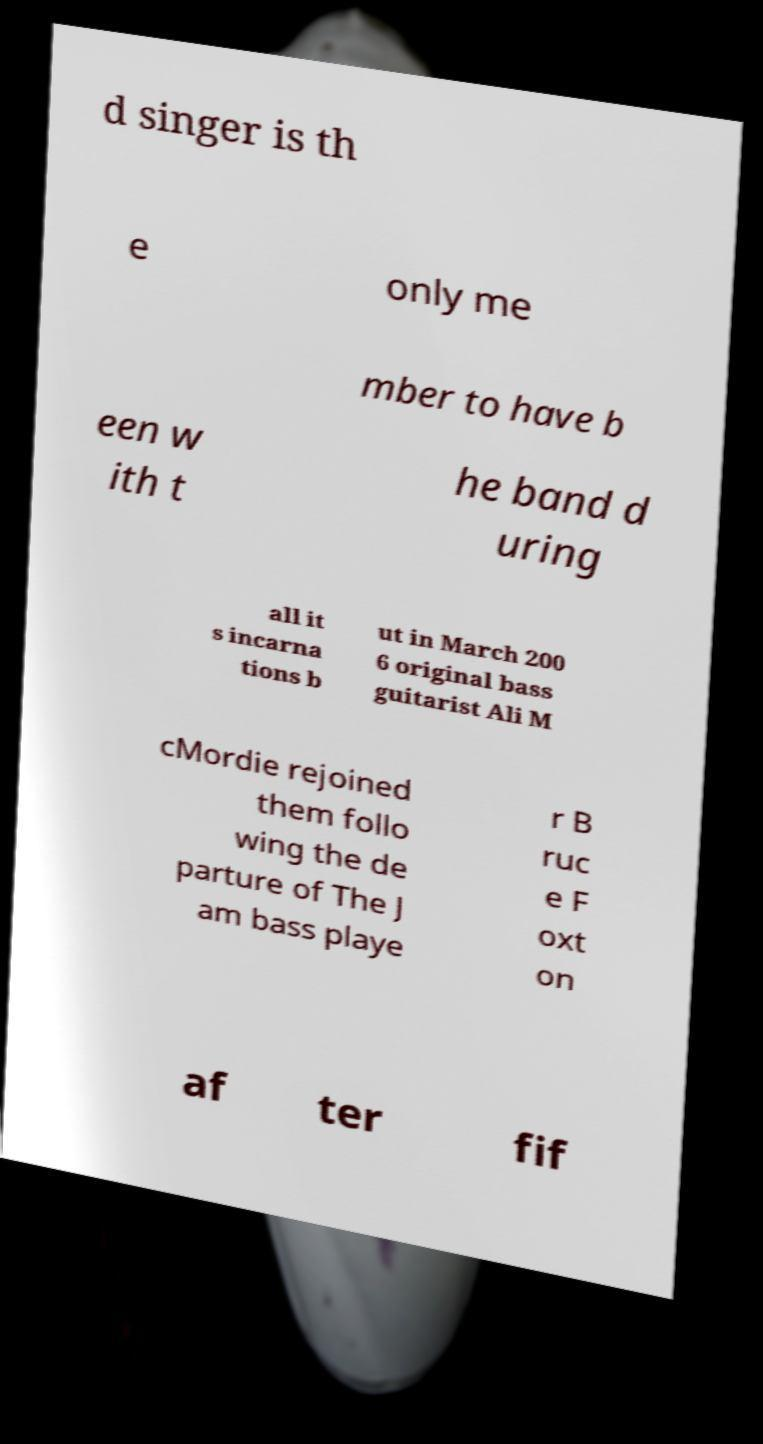Can you read and provide the text displayed in the image?This photo seems to have some interesting text. Can you extract and type it out for me? d singer is th e only me mber to have b een w ith t he band d uring all it s incarna tions b ut in March 200 6 original bass guitarist Ali M cMordie rejoined them follo wing the de parture of The J am bass playe r B ruc e F oxt on af ter fif 